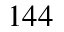<formula> <loc_0><loc_0><loc_500><loc_500>1 4 4</formula> 